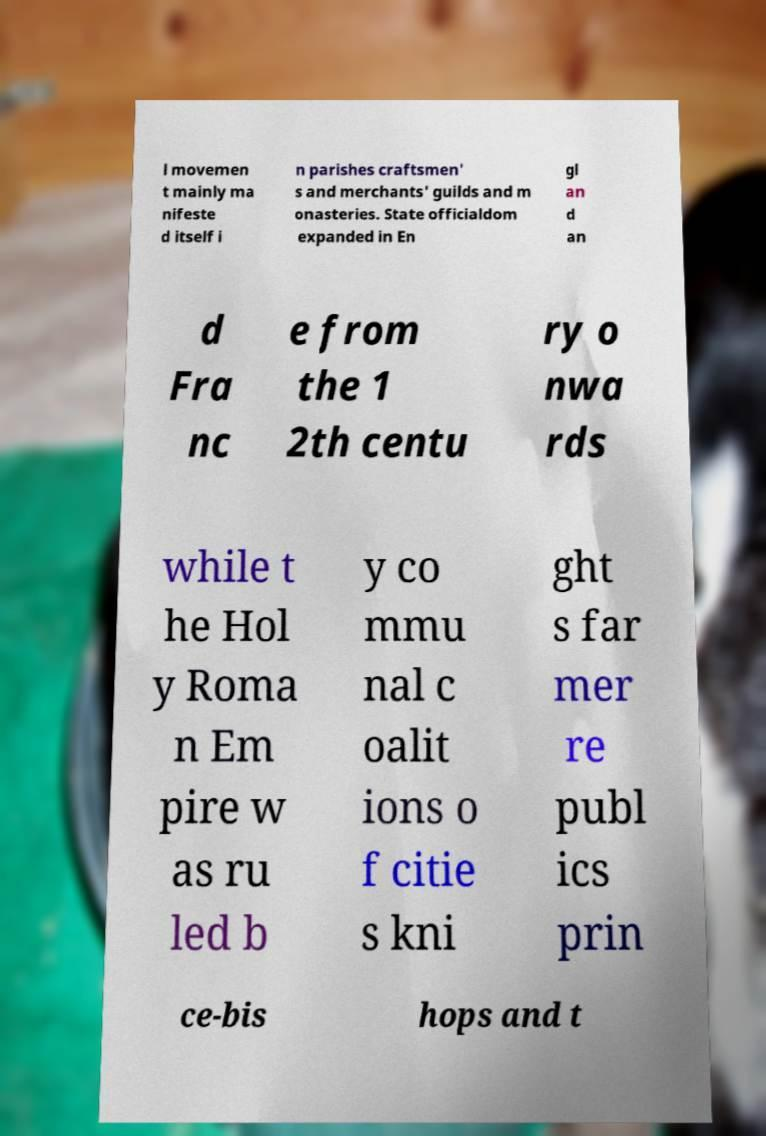There's text embedded in this image that I need extracted. Can you transcribe it verbatim? l movemen t mainly ma nifeste d itself i n parishes craftsmen' s and merchants' guilds and m onasteries. State officialdom expanded in En gl an d an d Fra nc e from the 1 2th centu ry o nwa rds while t he Hol y Roma n Em pire w as ru led b y co mmu nal c oalit ions o f citie s kni ght s far mer re publ ics prin ce-bis hops and t 